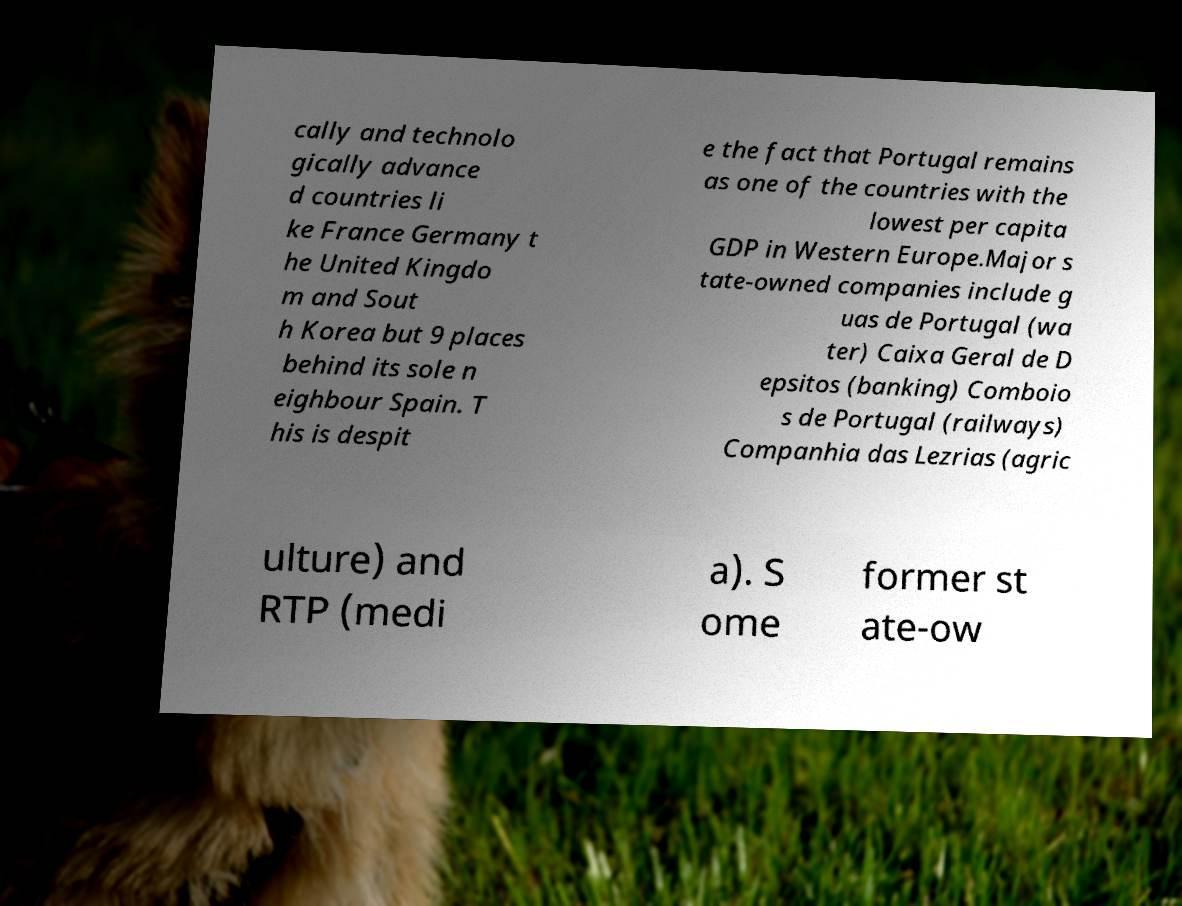What messages or text are displayed in this image? I need them in a readable, typed format. cally and technolo gically advance d countries li ke France Germany t he United Kingdo m and Sout h Korea but 9 places behind its sole n eighbour Spain. T his is despit e the fact that Portugal remains as one of the countries with the lowest per capita GDP in Western Europe.Major s tate-owned companies include g uas de Portugal (wa ter) Caixa Geral de D epsitos (banking) Comboio s de Portugal (railways) Companhia das Lezrias (agric ulture) and RTP (medi a). S ome former st ate-ow 